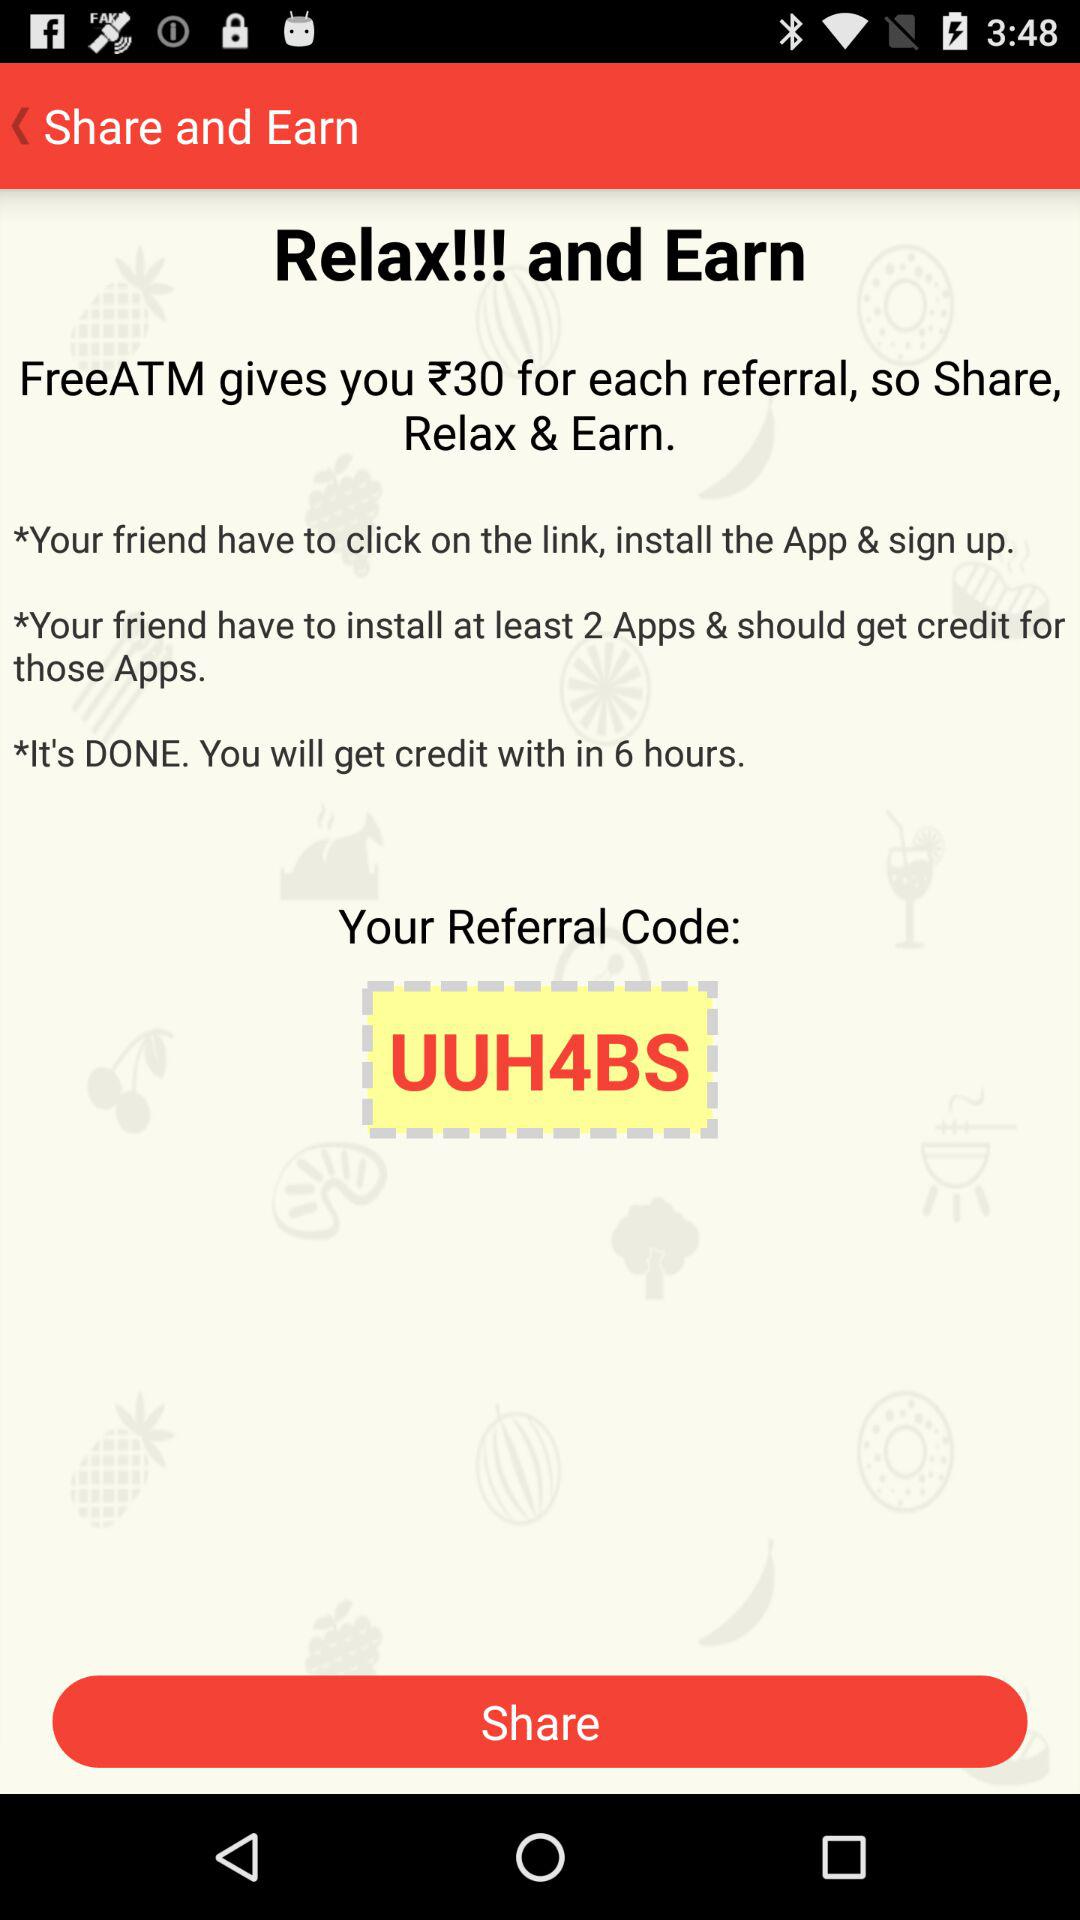What is the referral code? The referral code is "UUH4BS". 